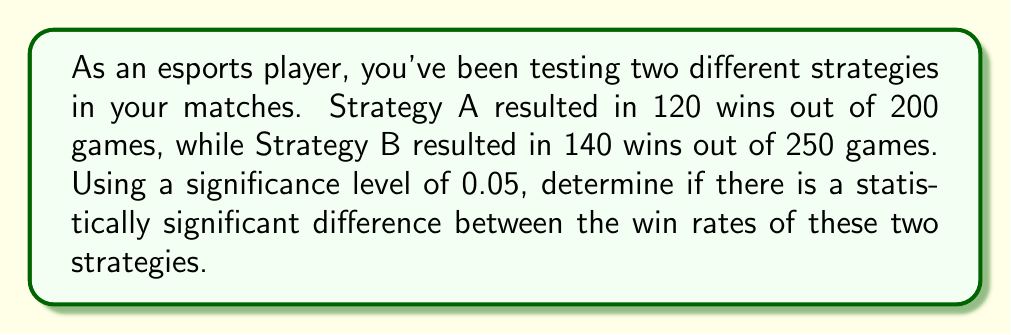Solve this math problem. Let's approach this step-by-step using a two-proportion z-test:

1) First, we need to calculate the sample proportions:
   Strategy A: $p_1 = \frac{120}{200} = 0.6$
   Strategy B: $p_2 = \frac{140}{250} = 0.56$

2) Now, we calculate the pooled proportion:
   $$p = \frac{x_1 + x_2}{n_1 + n_2} = \frac{120 + 140}{200 + 250} = \frac{260}{450} \approx 0.5778$$

3) Next, we calculate the standard error:
   $$SE = \sqrt{p(1-p)(\frac{1}{n_1} + \frac{1}{n_2})} = \sqrt{0.5778(1-0.5778)(\frac{1}{200} + \frac{1}{250})} \approx 0.0477$$

4) Now we can calculate the z-score:
   $$z = \frac{p_1 - p_2}{SE} = \frac{0.6 - 0.56}{0.0477} \approx 0.8386$$

5) For a two-tailed test at α = 0.05, the critical z-value is ±1.96.

6) Since our calculated z-score (0.8386) is less than the critical value (1.96), we fail to reject the null hypothesis.

Therefore, there is not enough evidence to conclude that there is a statistically significant difference between the win rates of the two strategies at the 0.05 significance level.
Answer: No significant difference (z = 0.8386 < 1.96) 